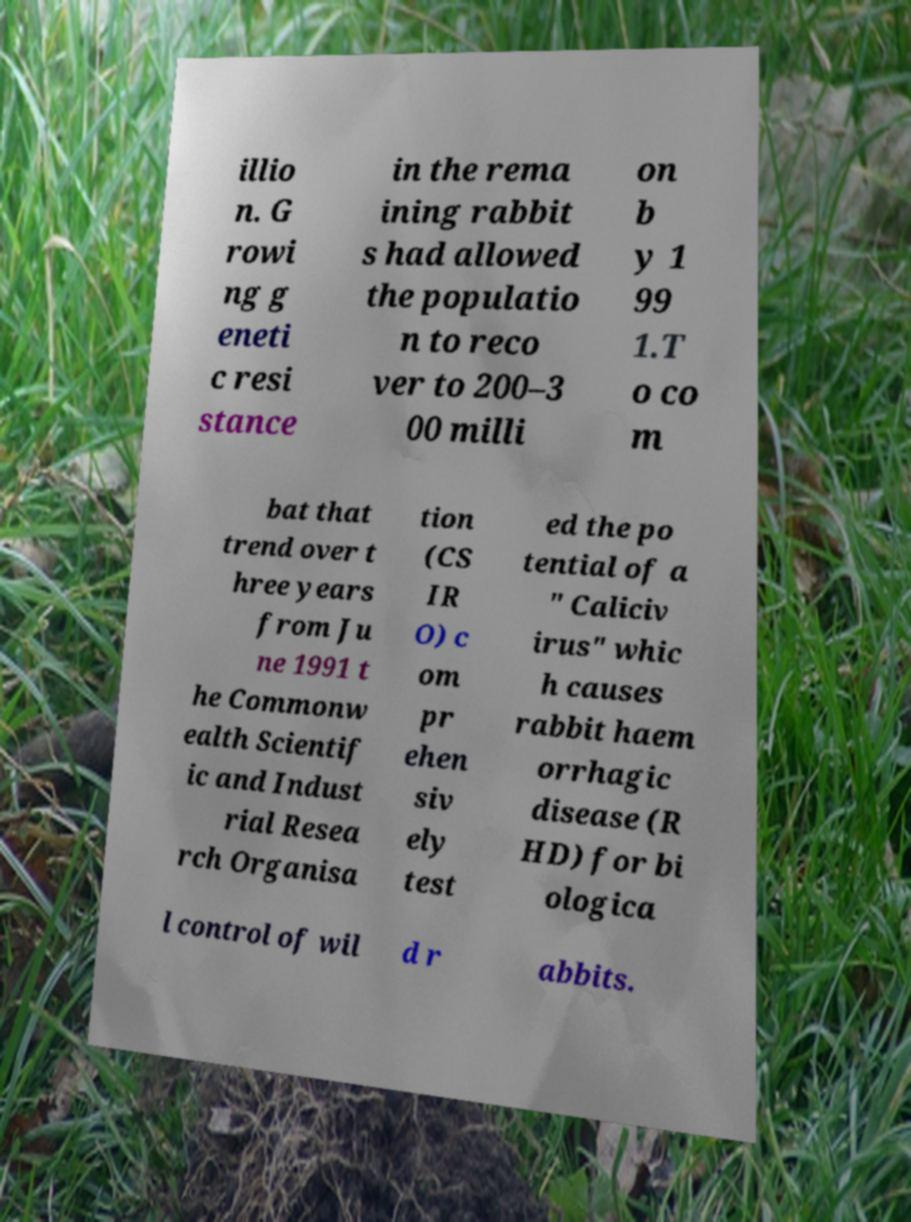Please identify and transcribe the text found in this image. illio n. G rowi ng g eneti c resi stance in the rema ining rabbit s had allowed the populatio n to reco ver to 200–3 00 milli on b y 1 99 1.T o co m bat that trend over t hree years from Ju ne 1991 t he Commonw ealth Scientif ic and Indust rial Resea rch Organisa tion (CS IR O) c om pr ehen siv ely test ed the po tential of a " Caliciv irus" whic h causes rabbit haem orrhagic disease (R HD) for bi ologica l control of wil d r abbits. 